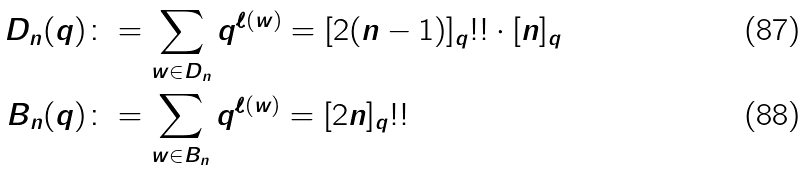<formula> <loc_0><loc_0><loc_500><loc_500>D _ { n } ( q ) & \colon = \sum _ { w \in D _ { n } } q ^ { \ell ( w ) } = [ 2 ( n - 1 ) ] _ { q } ! ! \cdot [ n ] _ { q } \\ B _ { n } ( q ) & \colon = \sum _ { w \in B _ { n } } q ^ { \ell ( w ) } = [ 2 n ] _ { q } ! !</formula> 